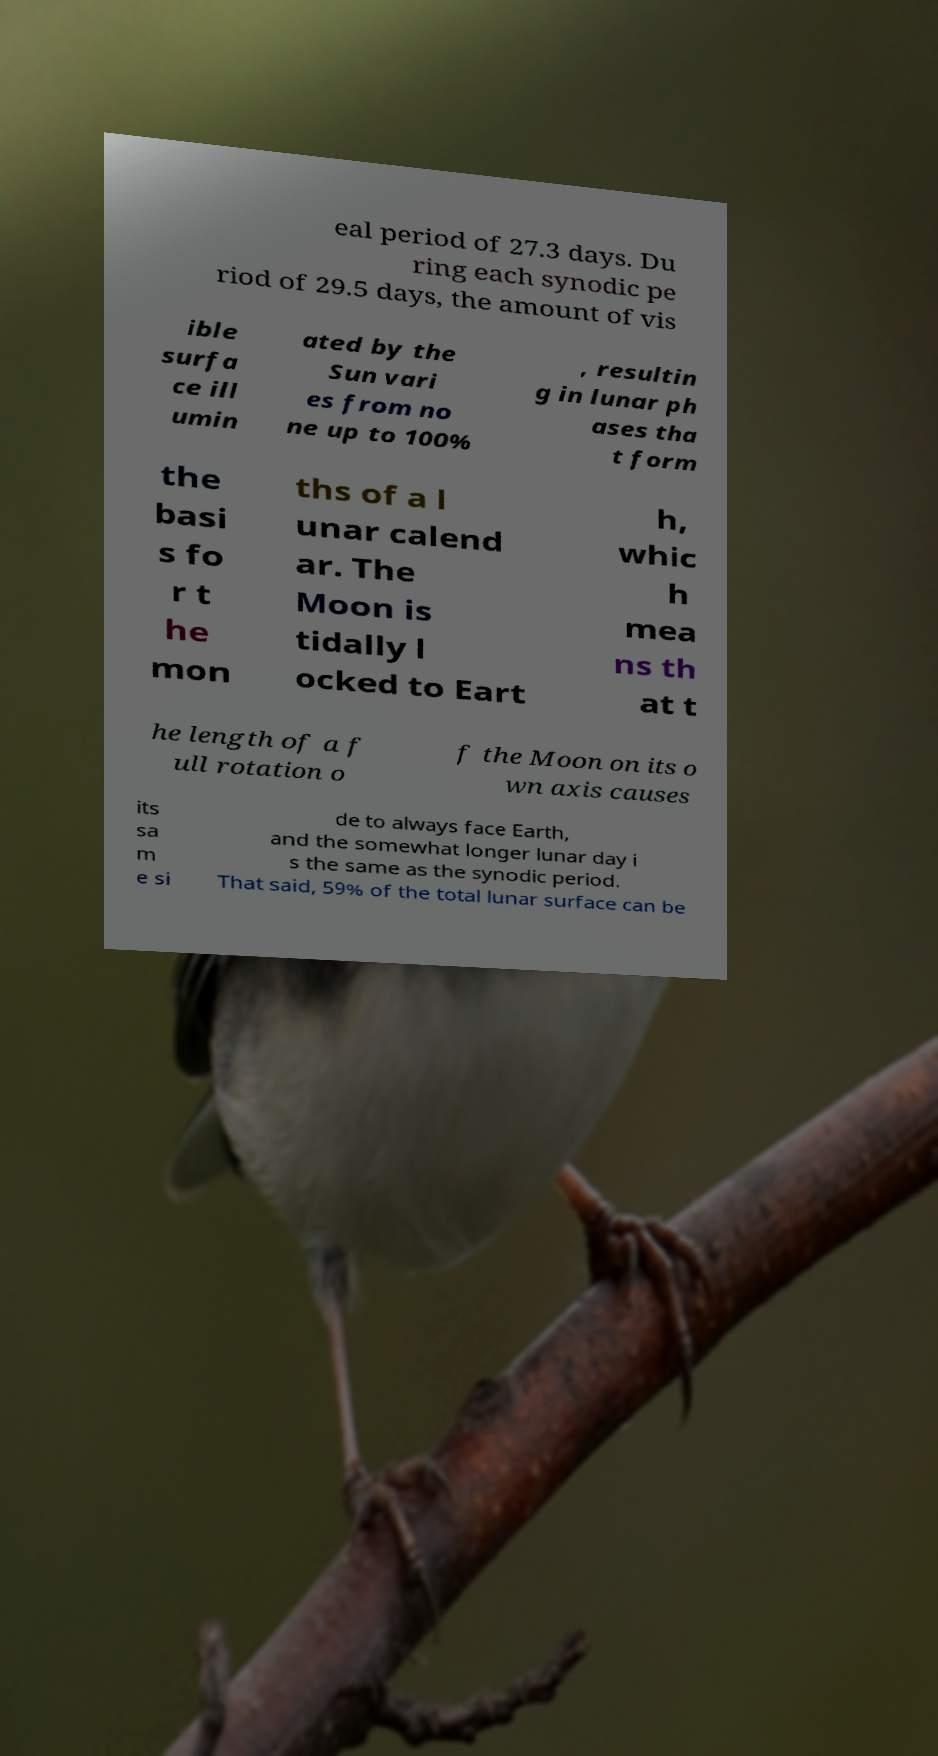Could you assist in decoding the text presented in this image and type it out clearly? eal period of 27.3 days. Du ring each synodic pe riod of 29.5 days, the amount of vis ible surfa ce ill umin ated by the Sun vari es from no ne up to 100% , resultin g in lunar ph ases tha t form the basi s fo r t he mon ths of a l unar calend ar. The Moon is tidally l ocked to Eart h, whic h mea ns th at t he length of a f ull rotation o f the Moon on its o wn axis causes its sa m e si de to always face Earth, and the somewhat longer lunar day i s the same as the synodic period. That said, 59% of the total lunar surface can be 